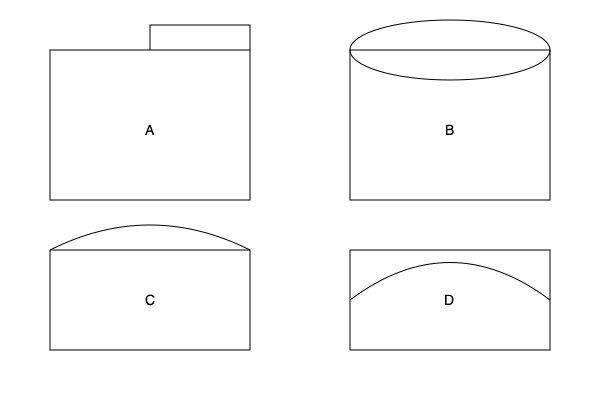As a Beethoven enthusiast, you're likely familiar with London's iconic concert venues. Match the architectural diagrams A, B, C, and D to their corresponding famous concert halls: Royal Albert Hall, Barbican Centre, Wigmore Hall, and Royal Festival Hall. To identify these concert halls, let's analyze their distinctive architectural features:

1. Diagram A: This shows a rectangular hall with a protruding triangular roof structure. This is characteristic of the Barbican Centre, known for its brutalist architecture and angular design.

2. Diagram B: The oval shape at the top of this rectangular structure is unmistakably the dome of the Royal Albert Hall, one of London's most recognizable concert venues.

3. Diagram C: This diagram depicts a smaller rectangular hall with a curved roof. This represents Wigmore Hall, famous for its intimate setting and excellent acoustics, often used for chamber music performances.

4. Diagram D: The sweeping curve above the rectangular structure is indicative of the Royal Festival Hall's iconic roof design, part of the Southbank Centre complex.

These venues are significant in London's classical music scene:
- Royal Albert Hall hosts the BBC Proms, where Beethoven's works are frequently performed.
- Barbican Centre is home to the London Symphony Orchestra, which regularly features Beethoven's symphonies.
- Wigmore Hall, while smaller, is renowned for its chamber music concerts, including Beethoven's string quartets.
- Royal Festival Hall, with its excellent acoustics, is a prime venue for orchestral performances of Beethoven's works.
Answer: A: Barbican Centre, B: Royal Albert Hall, C: Wigmore Hall, D: Royal Festival Hall 